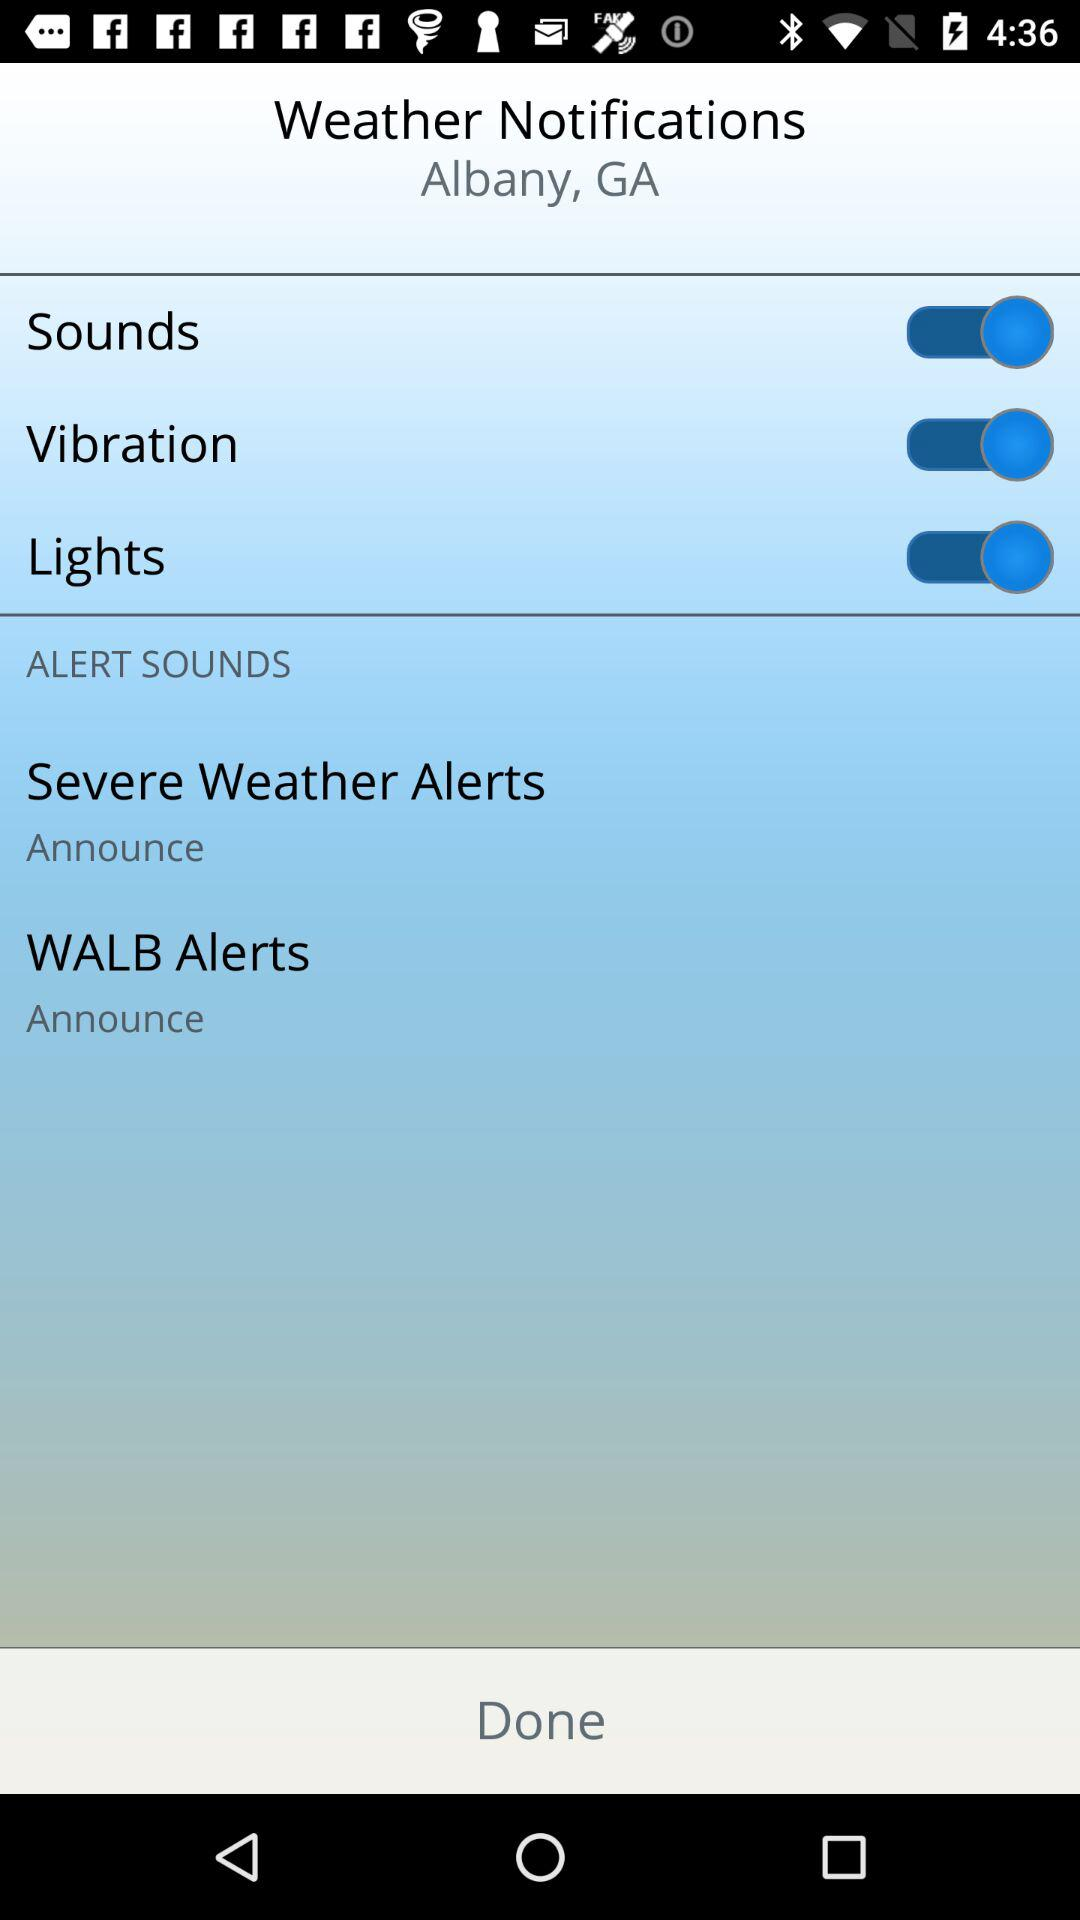How many alert sounds are there?
Answer the question using a single word or phrase. 2 